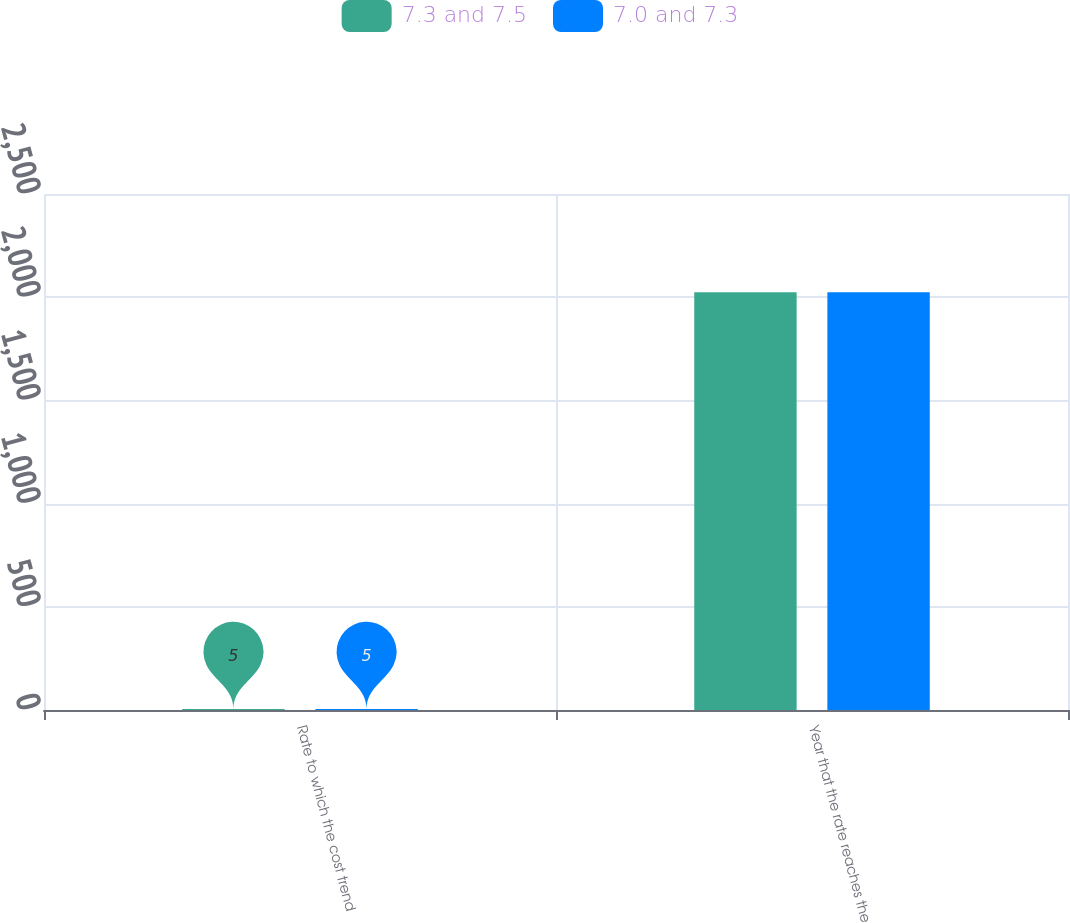Convert chart. <chart><loc_0><loc_0><loc_500><loc_500><stacked_bar_chart><ecel><fcel>Rate to which the cost trend<fcel>Year that the rate reaches the<nl><fcel>7.3 and 7.5<fcel>5<fcel>2024<nl><fcel>7.0 and 7.3<fcel>5<fcel>2024<nl></chart> 